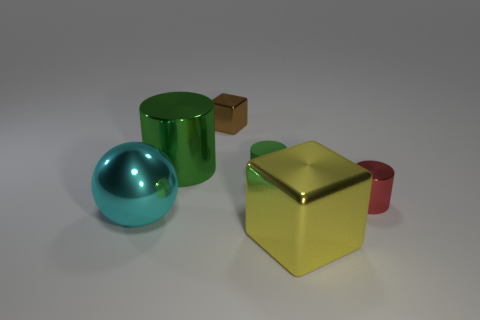Add 3 big shiny spheres. How many objects exist? 9 Subtract all balls. How many objects are left? 5 Add 4 tiny brown metal objects. How many tiny brown metal objects are left? 5 Add 1 gray balls. How many gray balls exist? 1 Subtract 0 gray spheres. How many objects are left? 6 Subtract all small brown metallic objects. Subtract all big shiny cylinders. How many objects are left? 4 